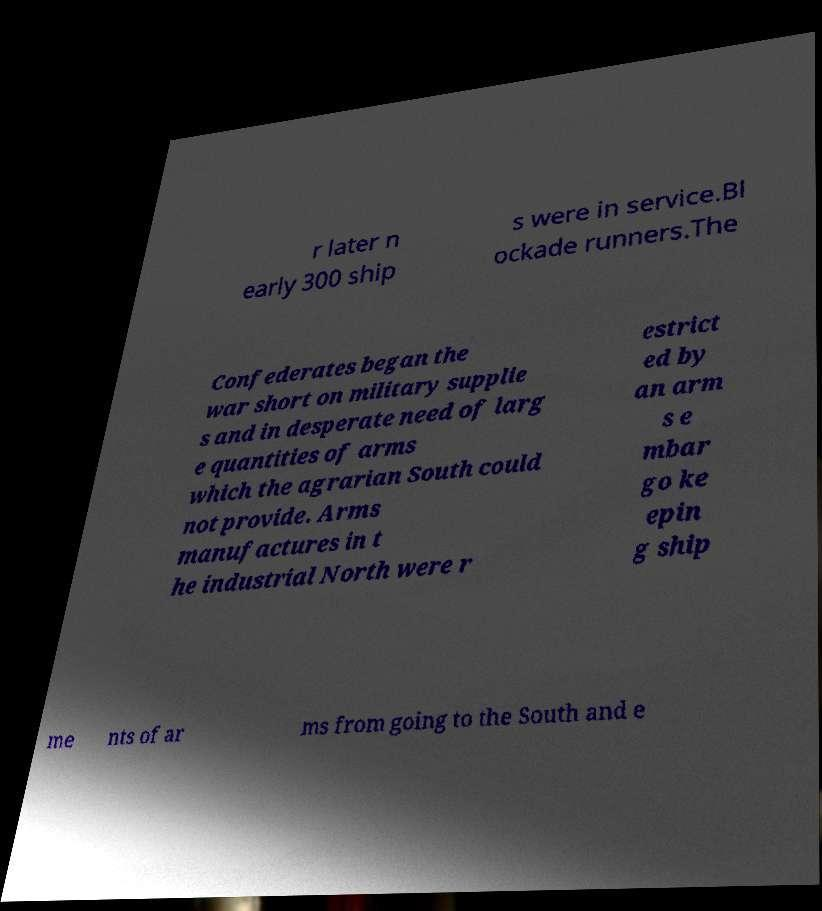What messages or text are displayed in this image? I need them in a readable, typed format. r later n early 300 ship s were in service.Bl ockade runners.The Confederates began the war short on military supplie s and in desperate need of larg e quantities of arms which the agrarian South could not provide. Arms manufactures in t he industrial North were r estrict ed by an arm s e mbar go ke epin g ship me nts of ar ms from going to the South and e 